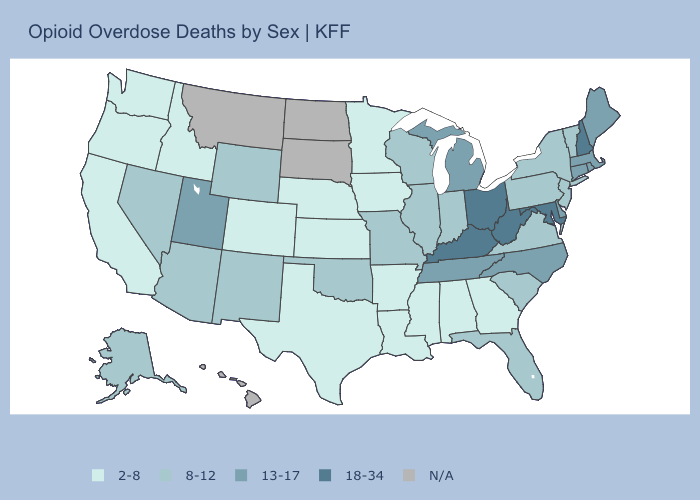What is the lowest value in the USA?
Concise answer only. 2-8. Name the states that have a value in the range 8-12?
Write a very short answer. Alaska, Arizona, Florida, Illinois, Indiana, Missouri, Nevada, New Jersey, New Mexico, New York, Oklahoma, Pennsylvania, South Carolina, Vermont, Virginia, Wisconsin, Wyoming. What is the lowest value in the USA?
Give a very brief answer. 2-8. What is the value of Maine?
Short answer required. 13-17. What is the highest value in states that border Nebraska?
Keep it brief. 8-12. Among the states that border Michigan , does Ohio have the lowest value?
Answer briefly. No. Among the states that border Pennsylvania , which have the lowest value?
Keep it brief. New Jersey, New York. Which states have the lowest value in the South?
Give a very brief answer. Alabama, Arkansas, Georgia, Louisiana, Mississippi, Texas. What is the value of Montana?
Answer briefly. N/A. What is the highest value in the USA?
Quick response, please. 18-34. Is the legend a continuous bar?
Short answer required. No. Which states have the lowest value in the USA?
Quick response, please. Alabama, Arkansas, California, Colorado, Georgia, Idaho, Iowa, Kansas, Louisiana, Minnesota, Mississippi, Nebraska, Oregon, Texas, Washington. Name the states that have a value in the range 13-17?
Keep it brief. Connecticut, Delaware, Maine, Massachusetts, Michigan, North Carolina, Rhode Island, Tennessee, Utah. What is the value of Mississippi?
Write a very short answer. 2-8. 